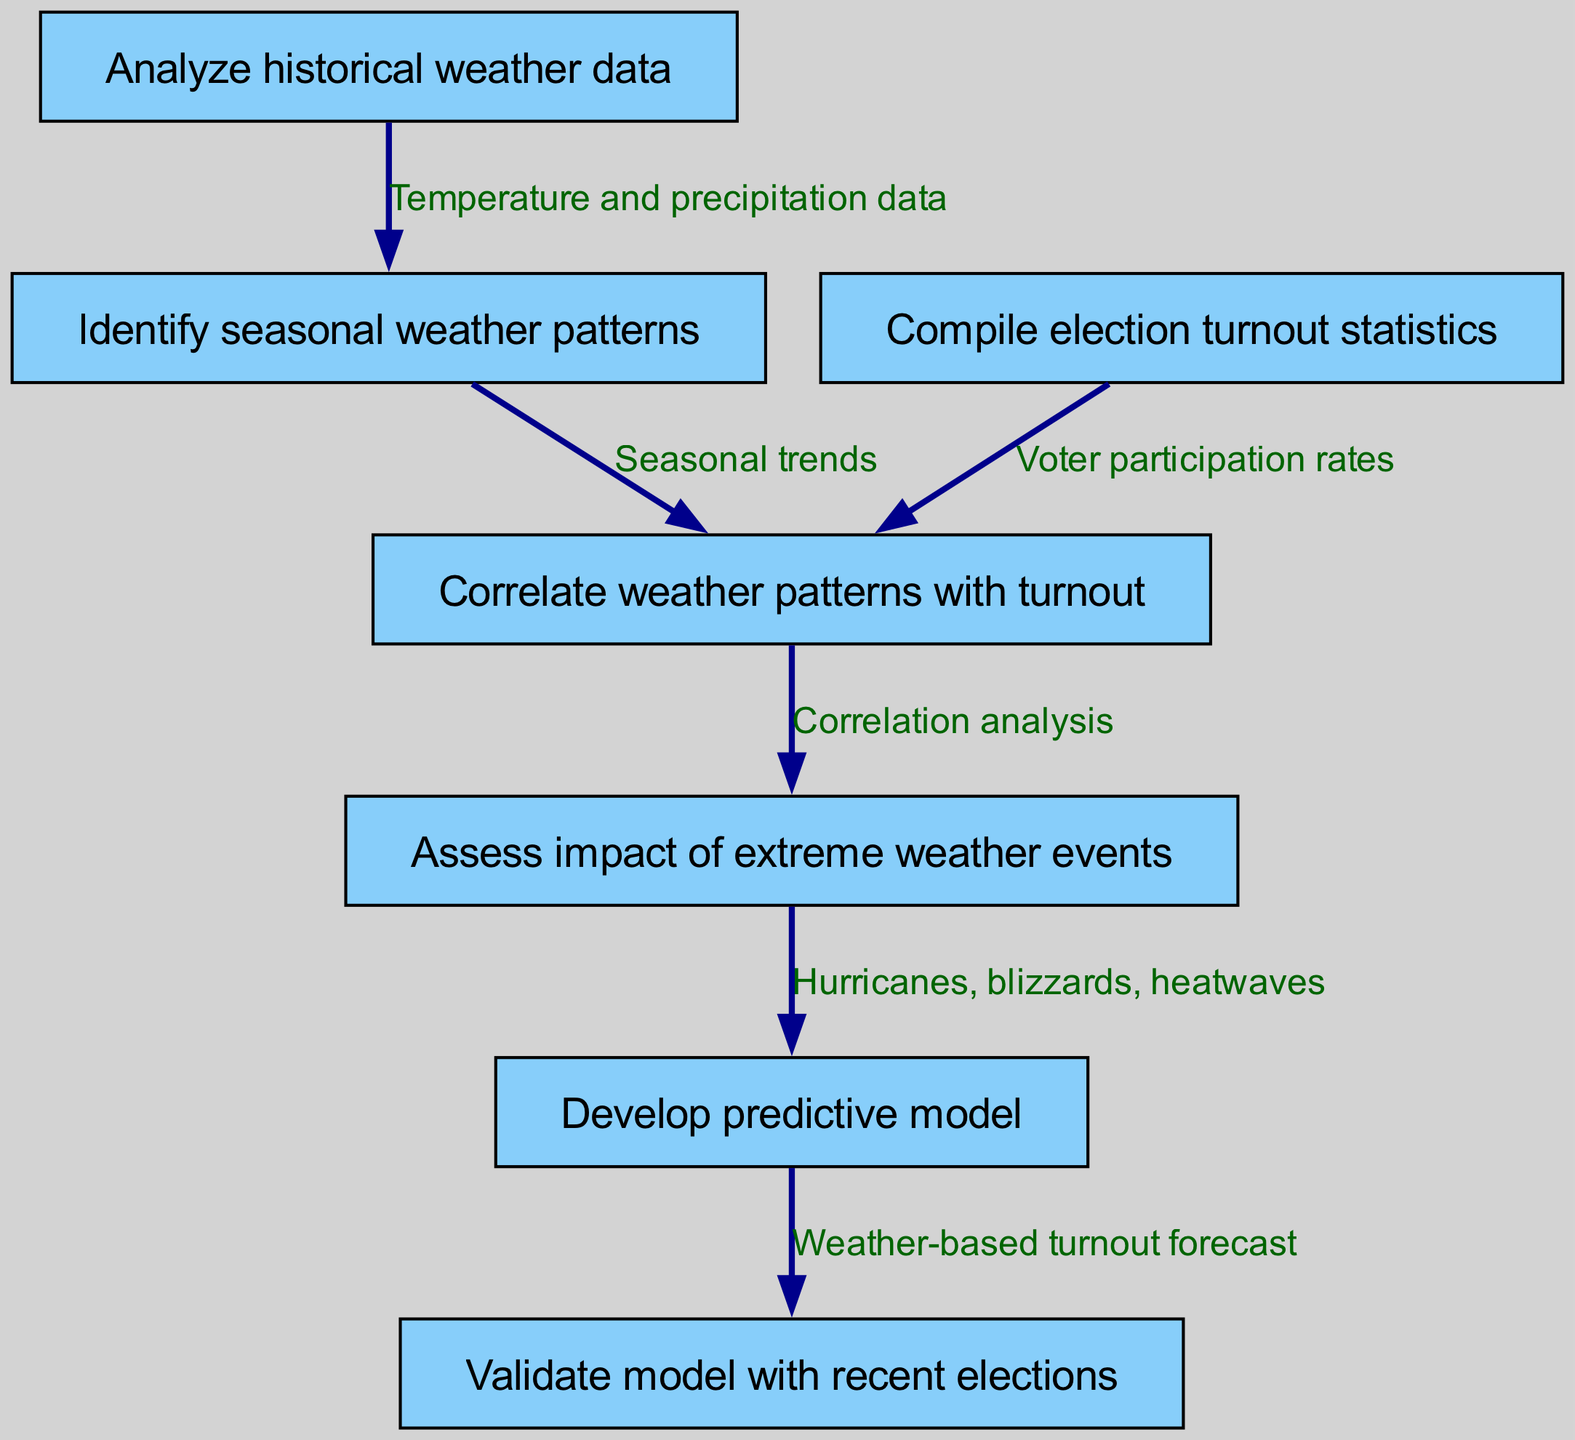What is the first step in the clinical pathway? The diagram starts with "Analyze historical weather data", which is clearly labeled as the first step (node 1).
Answer: Analyze historical weather data How many nodes are in the diagram? By counting the nodes listed in the data, there are a total of seven nodes present in the diagram.
Answer: 7 What is the relationship between "Identify seasonal weather patterns" and "Correlate weather patterns with turnout"? The diagram shows a direct line connecting node 3 ("Identify seasonal weather patterns") to node 4 ("Correlate weather patterns with turnout"), indicating a one-step linkage in the pathway.
Answer: Seasonal trends What step follows "Assess impact of extreme weather events"? The flow of the diagram indicates that after "Assess impact of extreme weather events" (node 5), the next step is to "Develop predictive model" (node 6).
Answer: Develop predictive model What does the connection between "Compile election turnout statistics" and "Correlate weather patterns with turnout" represent? The connection signifies that election turnout statistics (node 2) are essential for analyzing and establishing a correlation with weather patterns (node 4), indicating a dependency in the pathway.
Answer: Voter participation rates How does "Analyze historical weather data" influence the process? Historical weather data (node 1) is the foundational step leading to "Identify seasonal weather patterns" (node 3), making it crucial for understanding the correlation between weather and turnout.
Answer: Temperature and precipitation data What type of extreme weather events are assessed for their impact on turnout? The diagram specifies that hurricanes, blizzards, and heatwaves are the types of extreme weather events considered in the analysis.
Answer: Hurricanes, blizzards, heatwaves What is used to validate the predictive model? The validation of the predictive model is done with recent elections, as indicated by the arrow from node 6 to node 7.
Answer: Recent elections 